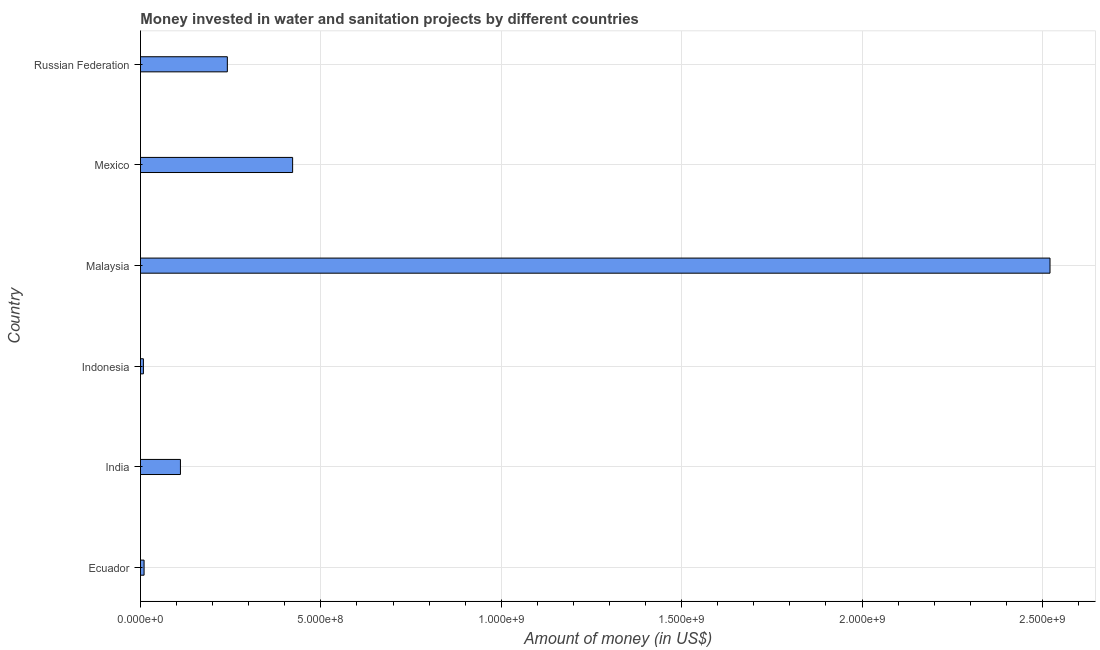What is the title of the graph?
Provide a succinct answer. Money invested in water and sanitation projects by different countries. What is the label or title of the X-axis?
Your response must be concise. Amount of money (in US$). What is the label or title of the Y-axis?
Keep it short and to the point. Country. What is the investment in Russian Federation?
Keep it short and to the point. 2.41e+08. Across all countries, what is the maximum investment?
Keep it short and to the point. 2.52e+09. Across all countries, what is the minimum investment?
Provide a short and direct response. 8.10e+06. In which country was the investment maximum?
Provide a succinct answer. Malaysia. What is the sum of the investment?
Provide a succinct answer. 3.31e+09. What is the difference between the investment in Ecuador and Russian Federation?
Provide a short and direct response. -2.31e+08. What is the average investment per country?
Give a very brief answer. 5.52e+08. What is the median investment?
Provide a short and direct response. 1.76e+08. In how many countries, is the investment greater than 900000000 US$?
Ensure brevity in your answer.  1. What is the ratio of the investment in Indonesia to that in Mexico?
Your answer should be very brief. 0.02. Is the difference between the investment in Malaysia and Russian Federation greater than the difference between any two countries?
Your response must be concise. No. What is the difference between the highest and the second highest investment?
Your answer should be very brief. 2.10e+09. What is the difference between the highest and the lowest investment?
Offer a terse response. 2.51e+09. How many bars are there?
Your answer should be compact. 6. Are all the bars in the graph horizontal?
Keep it short and to the point. Yes. What is the Amount of money (in US$) of Ecuador?
Your response must be concise. 1.00e+07. What is the Amount of money (in US$) in India?
Your answer should be very brief. 1.11e+08. What is the Amount of money (in US$) in Indonesia?
Make the answer very short. 8.10e+06. What is the Amount of money (in US$) in Malaysia?
Ensure brevity in your answer.  2.52e+09. What is the Amount of money (in US$) of Mexico?
Give a very brief answer. 4.22e+08. What is the Amount of money (in US$) of Russian Federation?
Offer a very short reply. 2.41e+08. What is the difference between the Amount of money (in US$) in Ecuador and India?
Make the answer very short. -1.01e+08. What is the difference between the Amount of money (in US$) in Ecuador and Indonesia?
Your response must be concise. 1.90e+06. What is the difference between the Amount of money (in US$) in Ecuador and Malaysia?
Your answer should be very brief. -2.51e+09. What is the difference between the Amount of money (in US$) in Ecuador and Mexico?
Provide a succinct answer. -4.12e+08. What is the difference between the Amount of money (in US$) in Ecuador and Russian Federation?
Offer a very short reply. -2.31e+08. What is the difference between the Amount of money (in US$) in India and Indonesia?
Offer a very short reply. 1.03e+08. What is the difference between the Amount of money (in US$) in India and Malaysia?
Your response must be concise. -2.41e+09. What is the difference between the Amount of money (in US$) in India and Mexico?
Your answer should be very brief. -3.11e+08. What is the difference between the Amount of money (in US$) in India and Russian Federation?
Provide a short and direct response. -1.30e+08. What is the difference between the Amount of money (in US$) in Indonesia and Malaysia?
Make the answer very short. -2.51e+09. What is the difference between the Amount of money (in US$) in Indonesia and Mexico?
Ensure brevity in your answer.  -4.14e+08. What is the difference between the Amount of money (in US$) in Indonesia and Russian Federation?
Make the answer very short. -2.33e+08. What is the difference between the Amount of money (in US$) in Malaysia and Mexico?
Offer a very short reply. 2.10e+09. What is the difference between the Amount of money (in US$) in Malaysia and Russian Federation?
Provide a short and direct response. 2.28e+09. What is the difference between the Amount of money (in US$) in Mexico and Russian Federation?
Your response must be concise. 1.81e+08. What is the ratio of the Amount of money (in US$) in Ecuador to that in India?
Make the answer very short. 0.09. What is the ratio of the Amount of money (in US$) in Ecuador to that in Indonesia?
Your answer should be compact. 1.24. What is the ratio of the Amount of money (in US$) in Ecuador to that in Malaysia?
Give a very brief answer. 0. What is the ratio of the Amount of money (in US$) in Ecuador to that in Mexico?
Keep it short and to the point. 0.02. What is the ratio of the Amount of money (in US$) in Ecuador to that in Russian Federation?
Your answer should be very brief. 0.04. What is the ratio of the Amount of money (in US$) in India to that in Indonesia?
Offer a very short reply. 13.67. What is the ratio of the Amount of money (in US$) in India to that in Malaysia?
Offer a terse response. 0.04. What is the ratio of the Amount of money (in US$) in India to that in Mexico?
Keep it short and to the point. 0.26. What is the ratio of the Amount of money (in US$) in India to that in Russian Federation?
Keep it short and to the point. 0.46. What is the ratio of the Amount of money (in US$) in Indonesia to that in Malaysia?
Provide a succinct answer. 0. What is the ratio of the Amount of money (in US$) in Indonesia to that in Mexico?
Keep it short and to the point. 0.02. What is the ratio of the Amount of money (in US$) in Indonesia to that in Russian Federation?
Your answer should be very brief. 0.03. What is the ratio of the Amount of money (in US$) in Malaysia to that in Mexico?
Provide a succinct answer. 5.98. What is the ratio of the Amount of money (in US$) in Malaysia to that in Russian Federation?
Keep it short and to the point. 10.47. What is the ratio of the Amount of money (in US$) in Mexico to that in Russian Federation?
Your response must be concise. 1.75. 